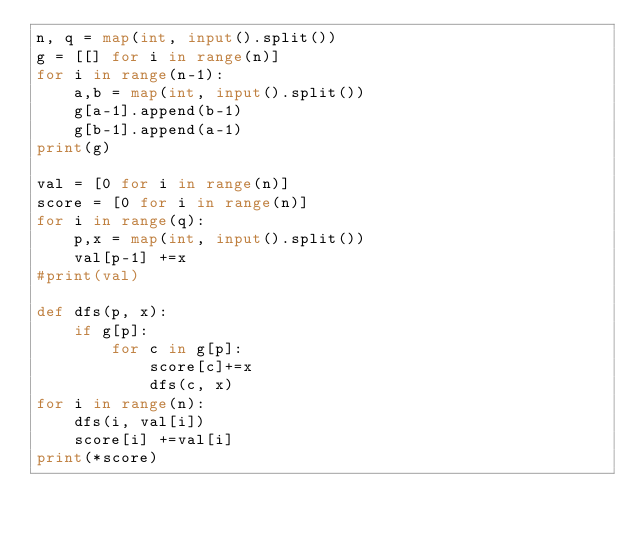Convert code to text. <code><loc_0><loc_0><loc_500><loc_500><_Python_>n, q = map(int, input().split())
g = [[] for i in range(n)]
for i in range(n-1):
    a,b = map(int, input().split())
    g[a-1].append(b-1)
    g[b-1].append(a-1)
print(g)
 
val = [0 for i in range(n)]
score = [0 for i in range(n)]
for i in range(q):
    p,x = map(int, input().split())
    val[p-1] +=x
#print(val)
 
def dfs(p, x):
    if g[p]:
        for c in g[p]:
            score[c]+=x
            dfs(c, x)
for i in range(n):
    dfs(i, val[i])
    score[i] +=val[i]
print(*score)</code> 